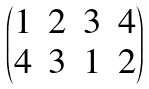<formula> <loc_0><loc_0><loc_500><loc_500>\begin{pmatrix} 1 & 2 & 3 & 4 \\ 4 & 3 & 1 & 2 \end{pmatrix}</formula> 